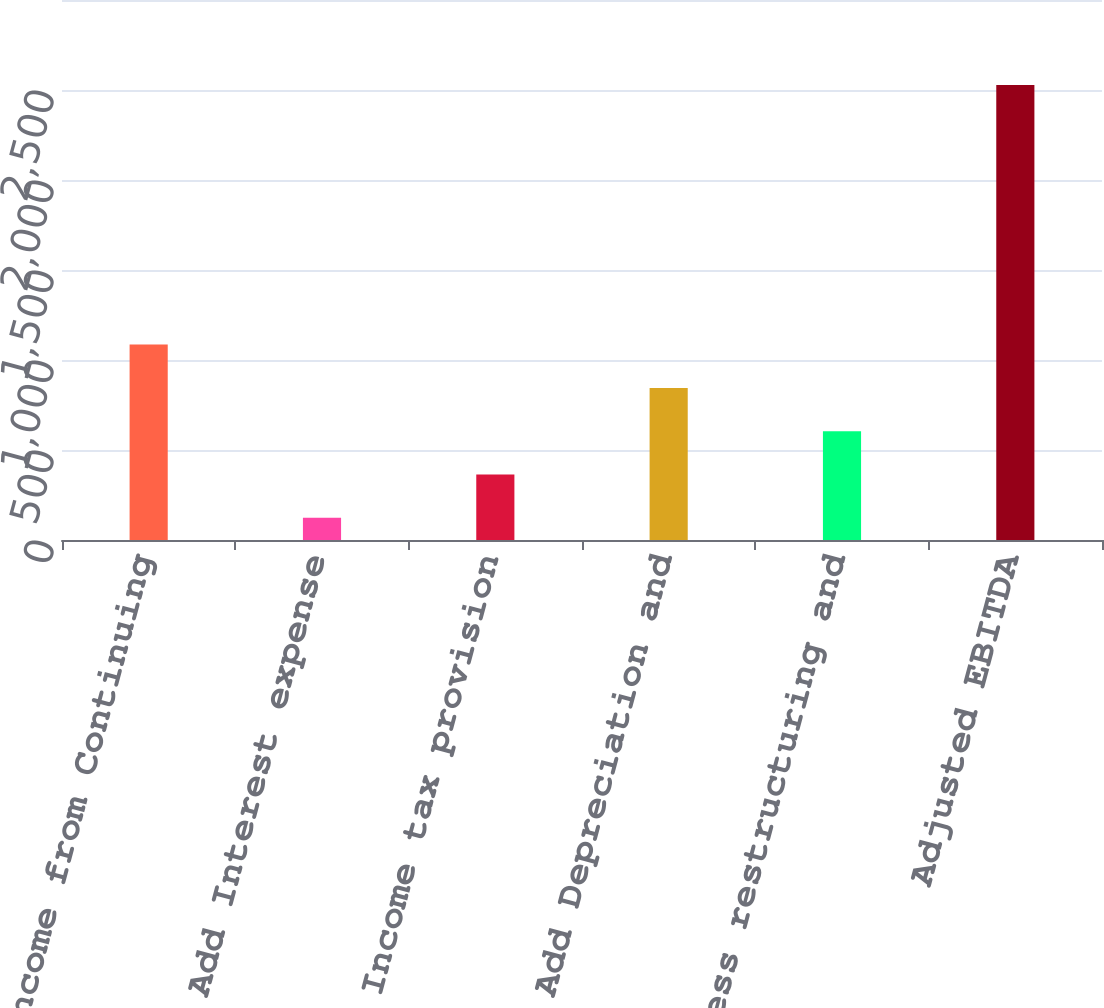Convert chart. <chart><loc_0><loc_0><loc_500><loc_500><bar_chart><fcel>Income from Continuing<fcel>Add Interest expense<fcel>Add Income tax provision<fcel>Add Depreciation and<fcel>Add Business restructuring and<fcel>Adjusted EBITDA<nl><fcel>1085.54<fcel>123.7<fcel>364.16<fcel>845.08<fcel>604.62<fcel>2528.3<nl></chart> 